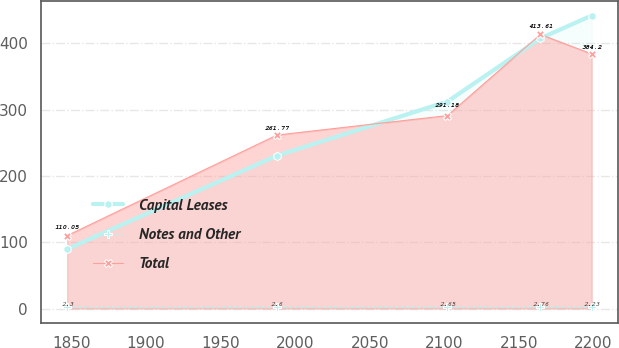Convert chart. <chart><loc_0><loc_0><loc_500><loc_500><line_chart><ecel><fcel>Capital Leases<fcel>Notes and Other<fcel>Total<nl><fcel>1847.22<fcel>89.66<fcel>2.3<fcel>110.05<nl><fcel>1987.88<fcel>230.81<fcel>2.6<fcel>261.77<nl><fcel>2102.16<fcel>312.35<fcel>2.65<fcel>291.18<nl><fcel>2164.48<fcel>407.8<fcel>2.76<fcel>413.61<nl><fcel>2198.9<fcel>442.16<fcel>2.23<fcel>384.2<nl></chart> 